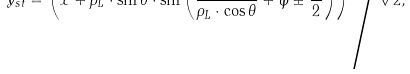<formula> <loc_0><loc_0><loc_500><loc_500>y _ { s t } = \left ( x + \rho _ { L } \cdot \sin { \theta } \cdot \sin { \left ( \frac { x } { \rho _ { L } \cdot \cos { \theta } } + \varphi \pm \frac { \pi } { 2 } \right ) } \right ) \Big / \sqrt { 2 } ,</formula> 